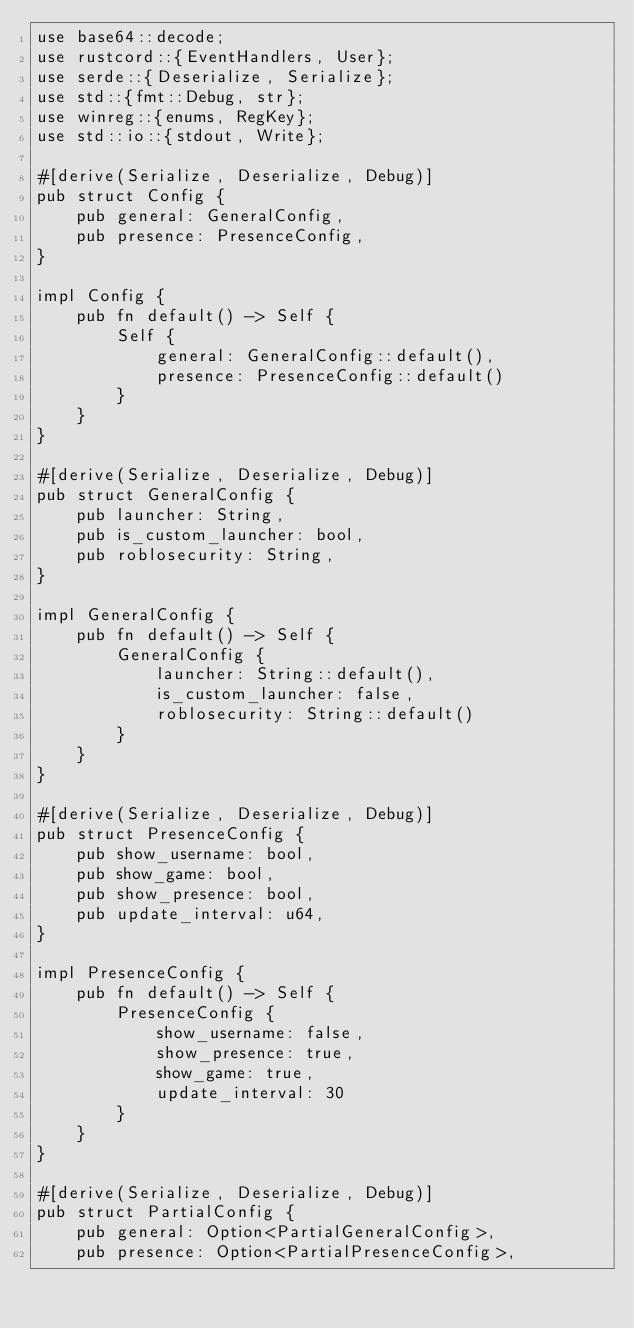Convert code to text. <code><loc_0><loc_0><loc_500><loc_500><_Rust_>use base64::decode;
use rustcord::{EventHandlers, User};
use serde::{Deserialize, Serialize};
use std::{fmt::Debug, str};
use winreg::{enums, RegKey};
use std::io::{stdout, Write};

#[derive(Serialize, Deserialize, Debug)]
pub struct Config {
    pub general: GeneralConfig,
    pub presence: PresenceConfig,
}

impl Config {
    pub fn default() -> Self {
        Self {
            general: GeneralConfig::default(),
            presence: PresenceConfig::default()
        }
    }
}

#[derive(Serialize, Deserialize, Debug)]
pub struct GeneralConfig {
    pub launcher: String,
    pub is_custom_launcher: bool,
    pub roblosecurity: String,
}

impl GeneralConfig {
    pub fn default() -> Self {
        GeneralConfig {
            launcher: String::default(),
            is_custom_launcher: false,
            roblosecurity: String::default()
        }
    }
}

#[derive(Serialize, Deserialize, Debug)]
pub struct PresenceConfig {
    pub show_username: bool,
    pub show_game: bool,
    pub show_presence: bool,
    pub update_interval: u64,
}

impl PresenceConfig {
    pub fn default() -> Self {
        PresenceConfig {
            show_username: false,
            show_presence: true,
            show_game: true,
            update_interval: 30
        }
    }
}

#[derive(Serialize, Deserialize, Debug)]
pub struct PartialConfig {
    pub general: Option<PartialGeneralConfig>,
    pub presence: Option<PartialPresenceConfig>,</code> 